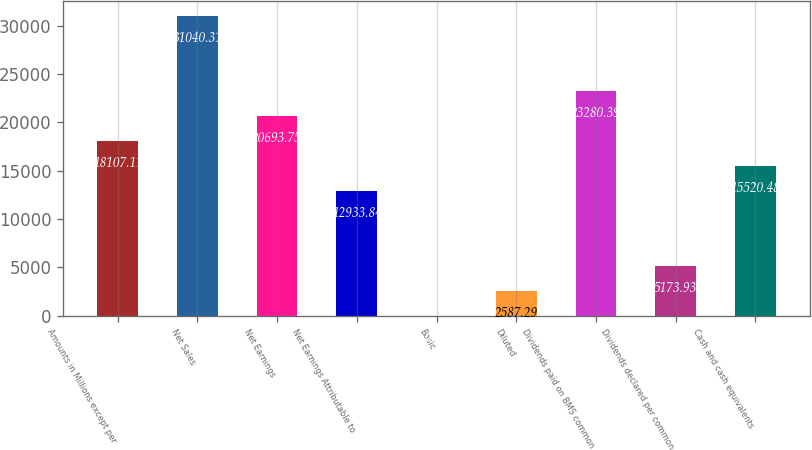Convert chart. <chart><loc_0><loc_0><loc_500><loc_500><bar_chart><fcel>Amounts in Millions except per<fcel>Net Sales<fcel>Net Earnings<fcel>Net Earnings Attributable to<fcel>Basic<fcel>Diluted<fcel>Dividends paid on BMS common<fcel>Dividends declared per common<fcel>Cash and cash equivalents<nl><fcel>18107.1<fcel>31040.3<fcel>20693.8<fcel>12933.8<fcel>0.65<fcel>2587.29<fcel>23280.4<fcel>5173.93<fcel>15520.5<nl></chart> 